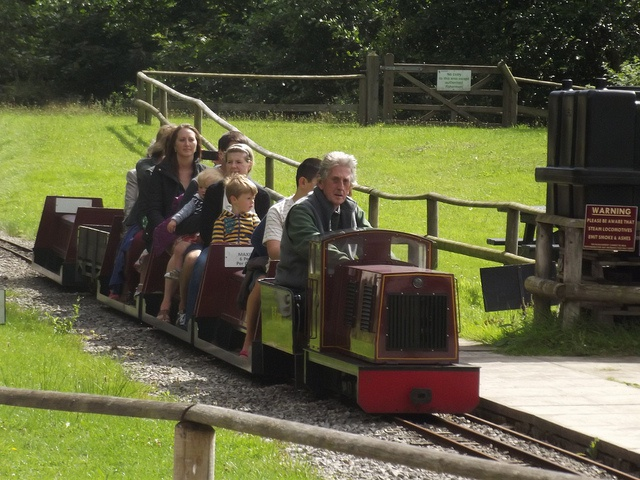Describe the objects in this image and their specific colors. I can see train in black, maroon, darkgreen, and gray tones, people in black, gray, and maroon tones, people in black, gray, and maroon tones, people in black, darkgray, maroon, and gray tones, and people in black, gray, and maroon tones in this image. 